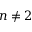Convert formula to latex. <formula><loc_0><loc_0><loc_500><loc_500>n \neq 2</formula> 